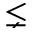Convert formula to latex. <formula><loc_0><loc_0><loc_500><loc_500>\lneq</formula> 